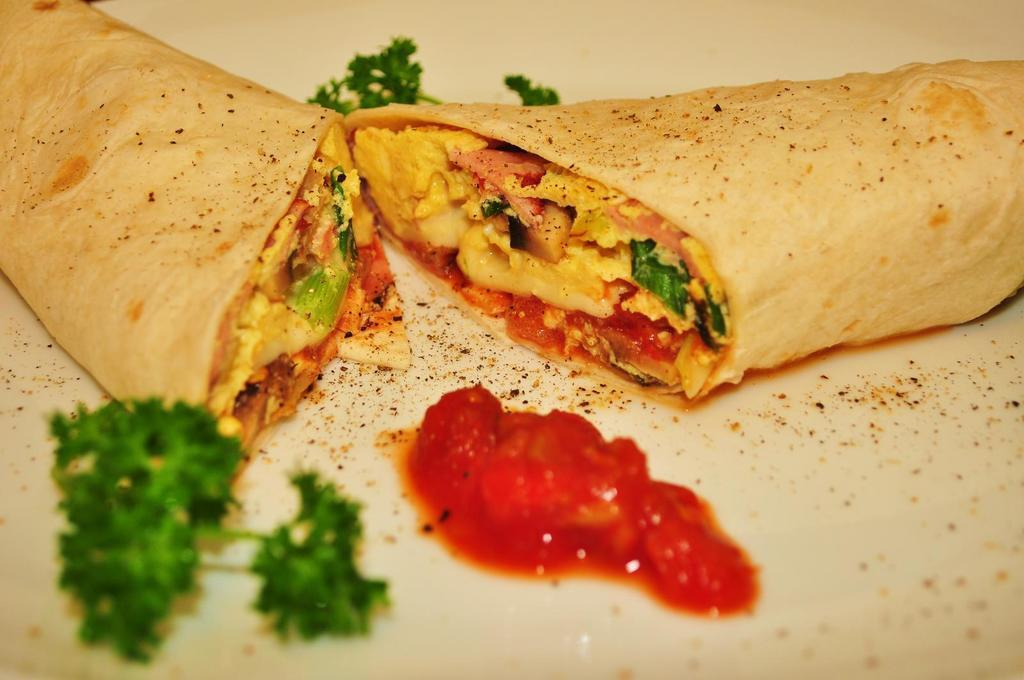What is on the plate in the image? There is food on a plate in the image. Can you describe the food on the plate? The food has some sauce on it, and leafy vegetables are present on the plate. What type of rhythm can be heard in the background of the image? There is no audible rhythm present in the image, as it is a still image of food on a plate. 